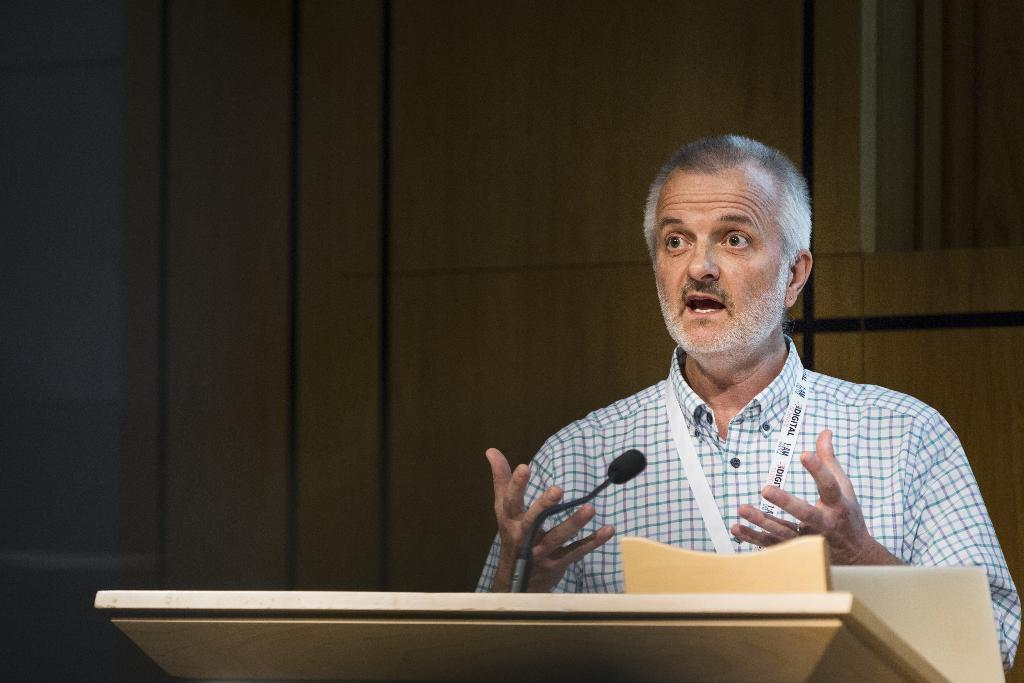Who is present in the image? There is a man in the image. What is the man wearing? The man is wearing a shirt. Does the man have any identifiers in the image? Yes, the man has an ID tag. What objects can be seen at the bottom of the image? There is a podium and a microphone at the bottom of the image. What is visible in the background of the image? The background of the image includes a wall. What type of agreement is being discussed at the podium in the image? There is no indication of an agreement being discussed in the image; it only shows a man, a shirt, an ID tag, a podium, a microphone, and a wall in the background. 